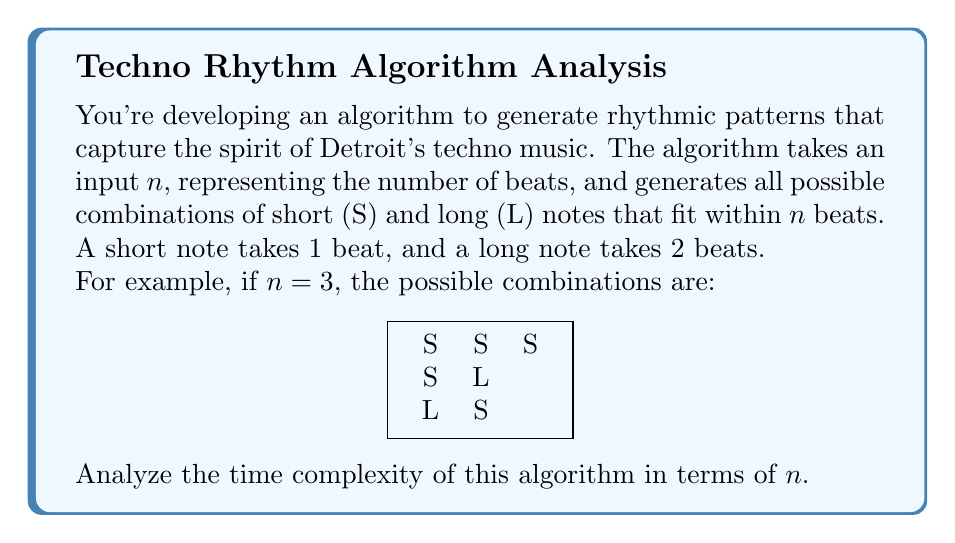Help me with this question. Let's break this down step-by-step:

1) First, we need to understand what the algorithm is doing. For each beat, we have two choices: place a short note (S) or start a long note (L).

2) If we place a short note, we move to the next beat. If we place a long note, we skip the next beat.

3) This process creates a binary tree of possibilities, where each path from root to leaf represents a valid combination.

4) The depth of this tree is at most $n$, as we make at most $n$ decisions (one per beat).

5) However, some branches of the tree will be shorter due to long notes taking two beats.

6) The number of leaf nodes in this tree represents the number of possible combinations, which is our algorithm's output.

7) This number of combinations is closely related to the Fibonacci sequence. Let $F(n)$ be the number of combinations for $n$ beats. We can observe:
   $F(1) = 1$ (S)
   $F(2) = 2$ (SS, L)
   $F(n) = F(n-1) + F(n-2)$ for $n > 2$

8) The Fibonacci sequence grows exponentially. Specifically, it grows at a rate of approximately $\phi^n$, where $\phi = \frac{1 + \sqrt{5}}{2} \approx 1.618$ is the golden ratio.

9) Therefore, the number of combinations our algorithm generates is $O(\phi^n)$.

10) Since the algorithm needs to generate and output all these combinations, its time complexity cannot be less than the number of combinations it produces.

Thus, the time complexity of the algorithm is $O(\phi^n)$, which is exponential.
Answer: $O(\phi^n)$, where $\phi \approx 1.618$ is the golden ratio 